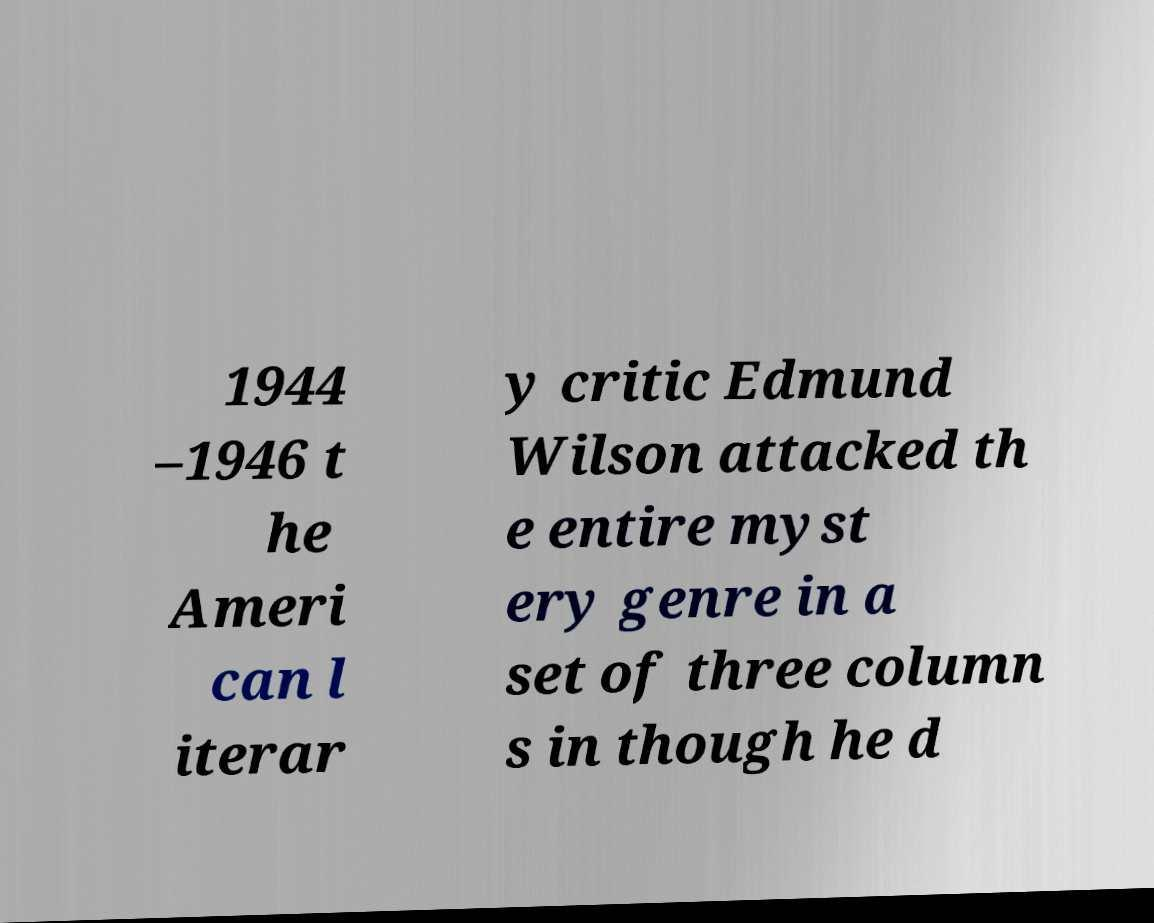Can you read and provide the text displayed in the image?This photo seems to have some interesting text. Can you extract and type it out for me? 1944 –1946 t he Ameri can l iterar y critic Edmund Wilson attacked th e entire myst ery genre in a set of three column s in though he d 